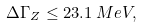<formula> <loc_0><loc_0><loc_500><loc_500>\Delta \Gamma _ { Z } \leq 2 3 . 1 \, M e V ,</formula> 